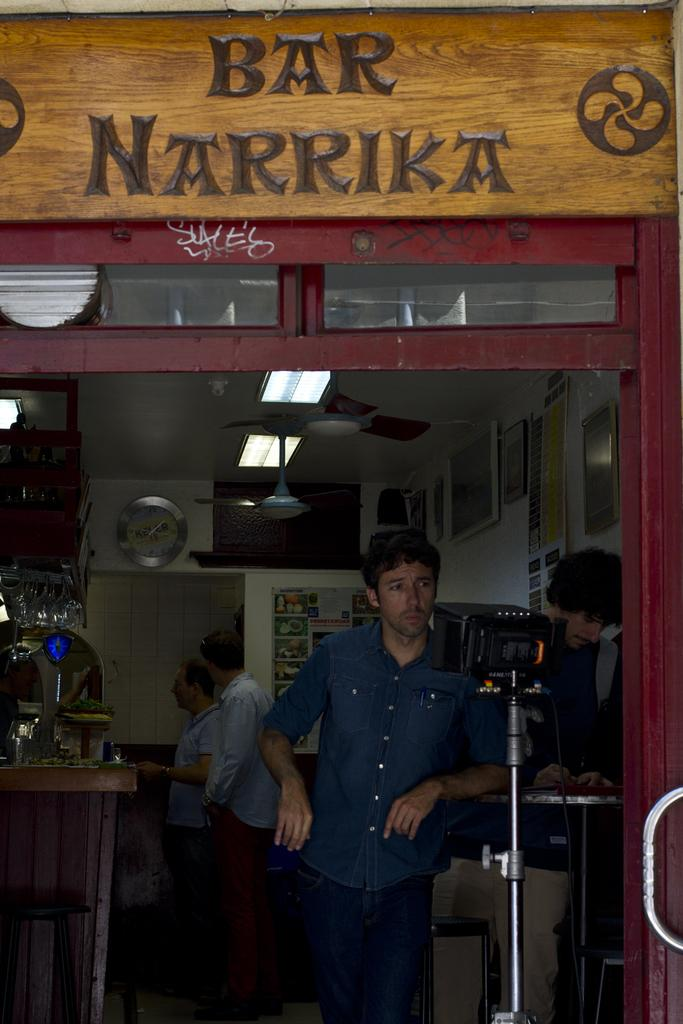<image>
Render a clear and concise summary of the photo. A man stands through the doorway of a store with a sign that says Bar Narrika above it. 